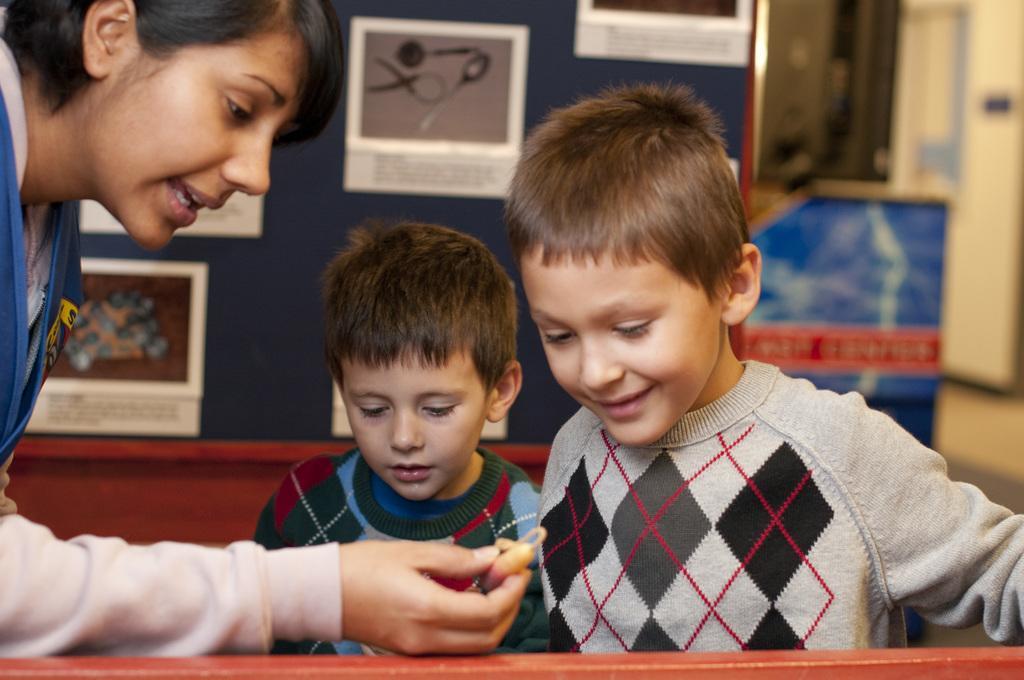How would you summarize this image in a sentence or two? In the foreground of this image, there are two boys and on the left, there is a woman holding an object. In the background, there are few posters on the wall and remaining objects are not clear. 